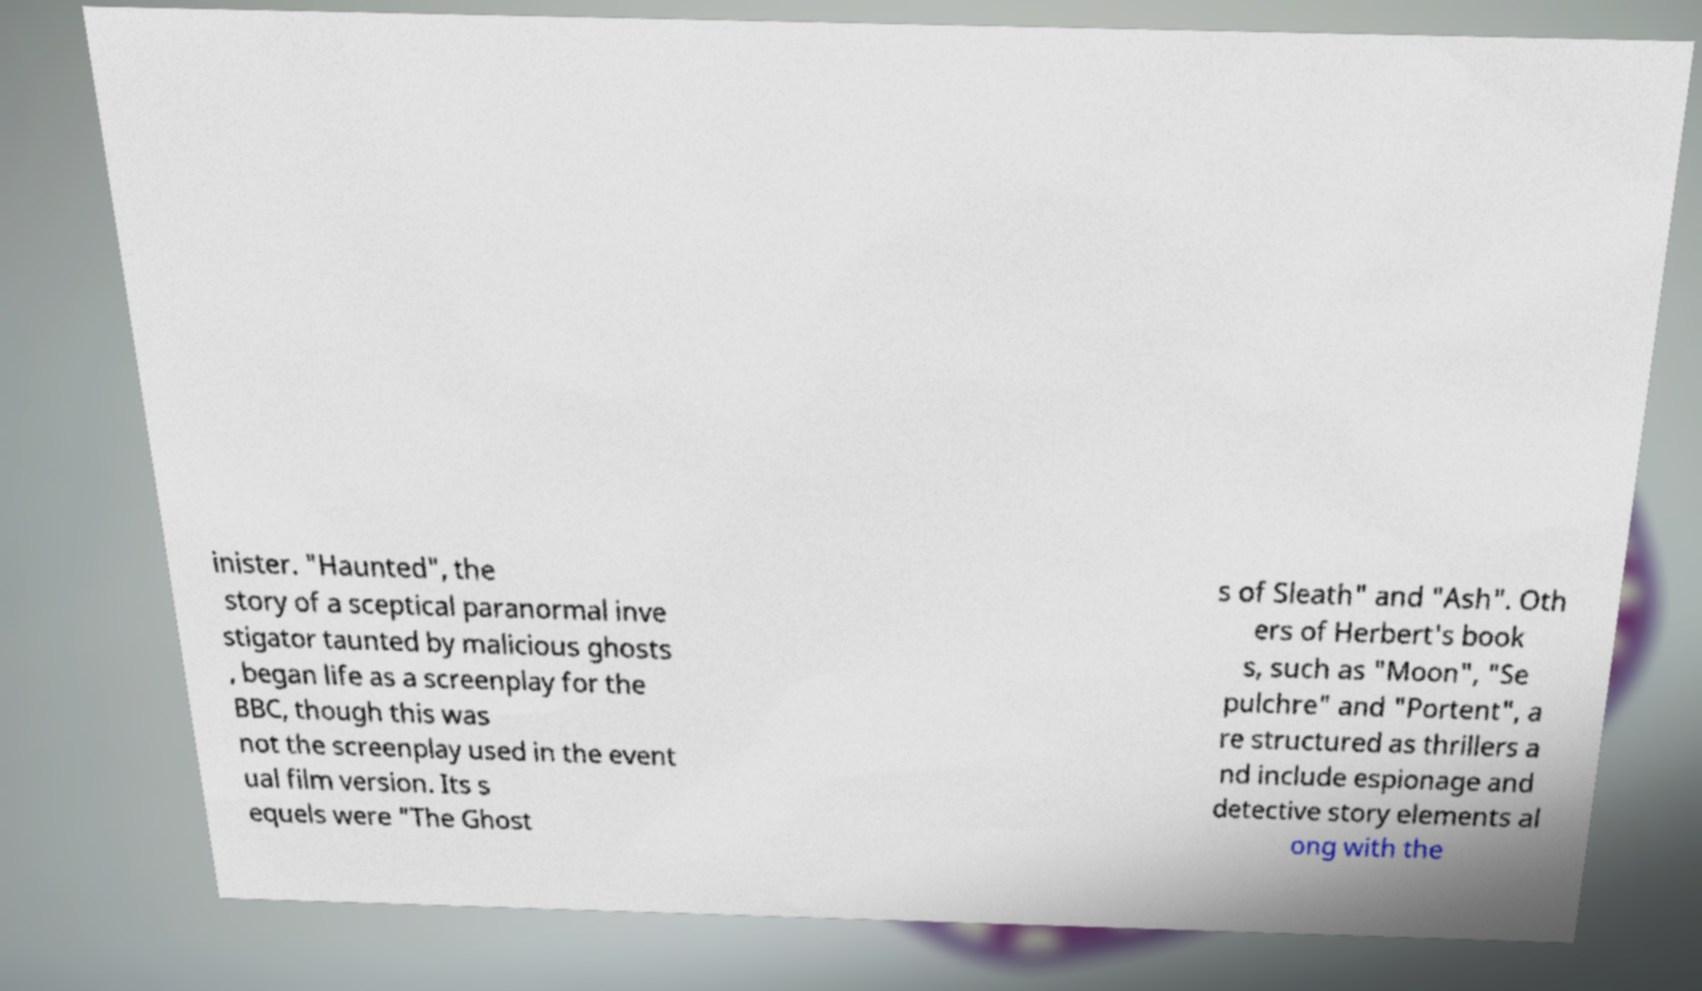Could you extract and type out the text from this image? inister. "Haunted", the story of a sceptical paranormal inve stigator taunted by malicious ghosts , began life as a screenplay for the BBC, though this was not the screenplay used in the event ual film version. Its s equels were "The Ghost s of Sleath" and "Ash". Oth ers of Herbert's book s, such as "Moon", "Se pulchre" and "Portent", a re structured as thrillers a nd include espionage and detective story elements al ong with the 